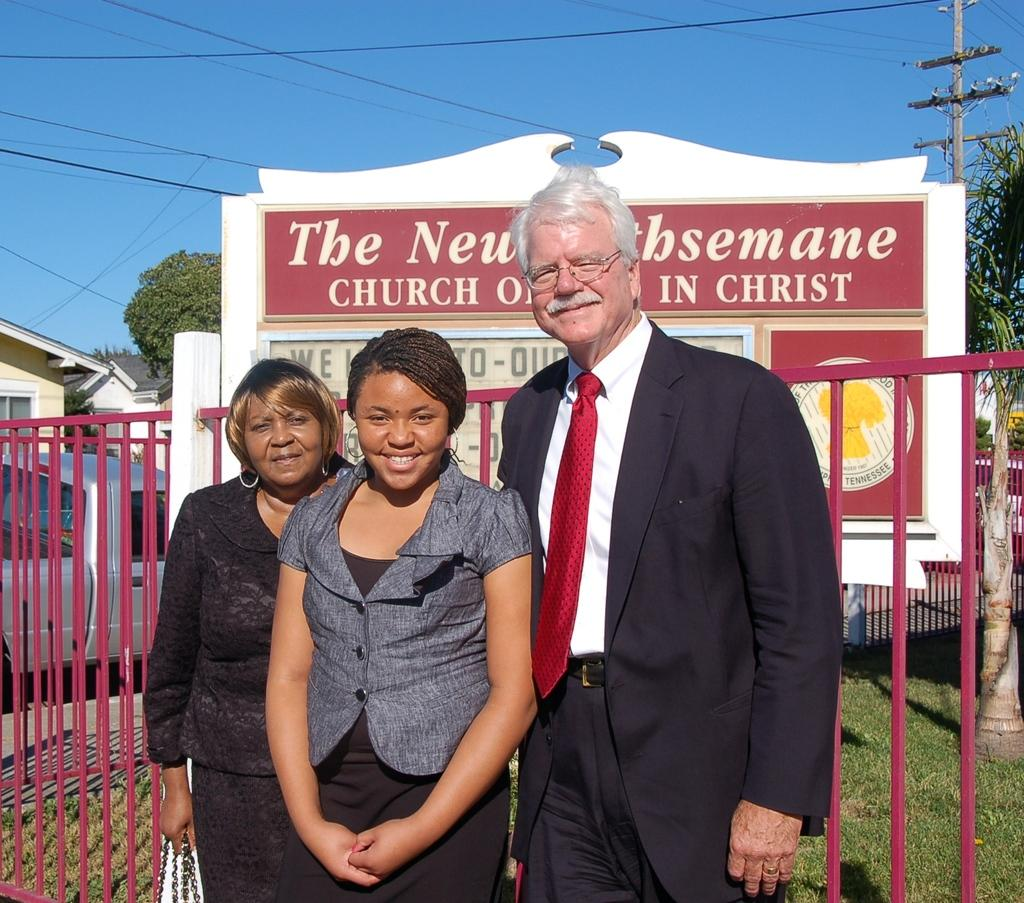How many people are standing on the path in the image? There are three people standing on the path in the image. What can be seen running along the path from left to right? There is fencing visible from left to right in the image. What is present in the background of the image? There is a board, trees, and buildings in the background of the image. What type of polish is being applied to the pest in the image? There is no polish or pest present in the image. What is the hope of the people standing on the path in the image? The image does not provide information about the hopes or intentions of the people standing on the path. 